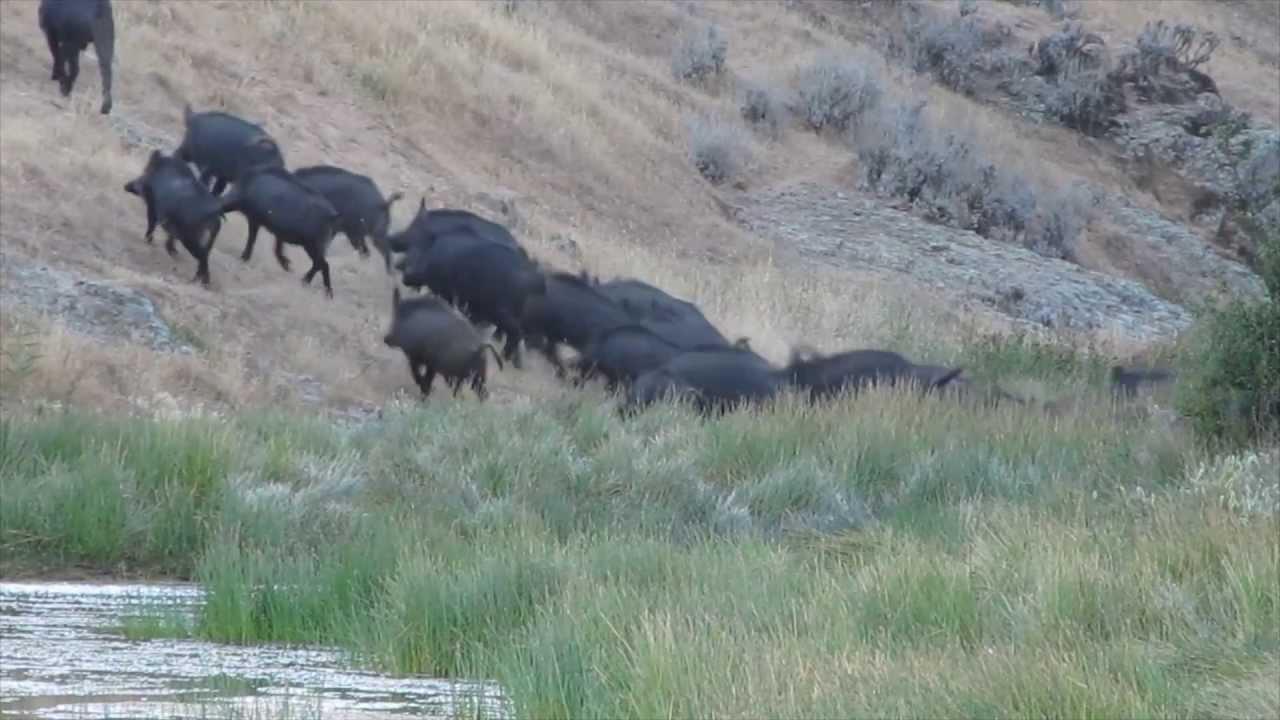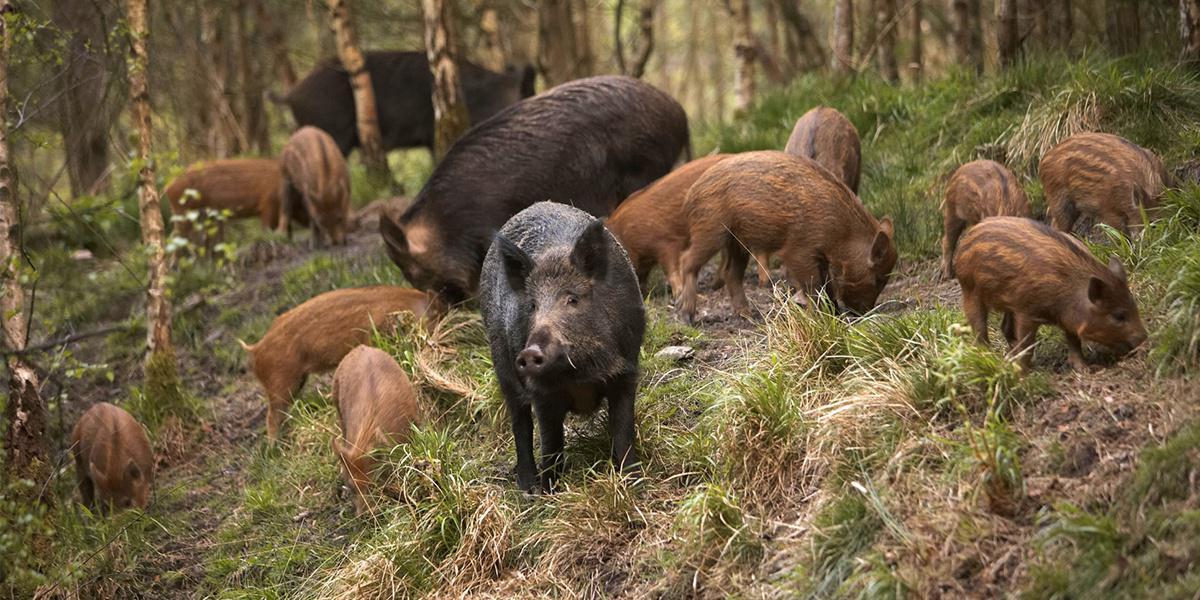The first image is the image on the left, the second image is the image on the right. Examine the images to the left and right. Is the description "Right image includes young hogs with distinctive striped coats." accurate? Answer yes or no. Yes. The first image is the image on the left, the second image is the image on the right. Evaluate the accuracy of this statement regarding the images: "A single boar is facing the camera". Is it true? Answer yes or no. Yes. 